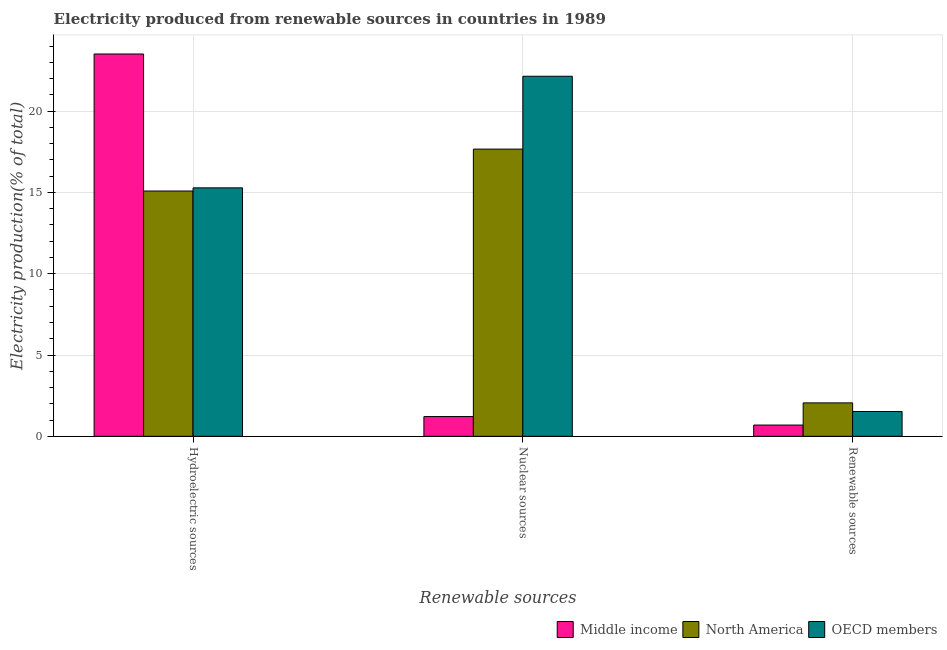How many different coloured bars are there?
Provide a succinct answer. 3. How many groups of bars are there?
Your answer should be very brief. 3. How many bars are there on the 3rd tick from the right?
Make the answer very short. 3. What is the label of the 3rd group of bars from the left?
Ensure brevity in your answer.  Renewable sources. What is the percentage of electricity produced by nuclear sources in North America?
Offer a very short reply. 17.66. Across all countries, what is the maximum percentage of electricity produced by hydroelectric sources?
Provide a short and direct response. 23.51. Across all countries, what is the minimum percentage of electricity produced by hydroelectric sources?
Offer a very short reply. 15.09. What is the total percentage of electricity produced by renewable sources in the graph?
Provide a succinct answer. 4.28. What is the difference between the percentage of electricity produced by nuclear sources in Middle income and that in North America?
Ensure brevity in your answer.  -16.45. What is the difference between the percentage of electricity produced by nuclear sources in North America and the percentage of electricity produced by renewable sources in Middle income?
Provide a short and direct response. 16.97. What is the average percentage of electricity produced by nuclear sources per country?
Provide a short and direct response. 13.68. What is the difference between the percentage of electricity produced by renewable sources and percentage of electricity produced by nuclear sources in North America?
Offer a very short reply. -15.61. In how many countries, is the percentage of electricity produced by nuclear sources greater than 7 %?
Make the answer very short. 2. What is the ratio of the percentage of electricity produced by nuclear sources in OECD members to that in North America?
Ensure brevity in your answer.  1.25. Is the percentage of electricity produced by renewable sources in North America less than that in OECD members?
Give a very brief answer. No. What is the difference between the highest and the second highest percentage of electricity produced by nuclear sources?
Offer a terse response. 4.48. What is the difference between the highest and the lowest percentage of electricity produced by nuclear sources?
Ensure brevity in your answer.  20.93. In how many countries, is the percentage of electricity produced by nuclear sources greater than the average percentage of electricity produced by nuclear sources taken over all countries?
Offer a very short reply. 2. How many bars are there?
Give a very brief answer. 9. How many countries are there in the graph?
Your answer should be very brief. 3. Does the graph contain any zero values?
Give a very brief answer. No. Does the graph contain grids?
Keep it short and to the point. Yes. Where does the legend appear in the graph?
Give a very brief answer. Bottom right. What is the title of the graph?
Make the answer very short. Electricity produced from renewable sources in countries in 1989. What is the label or title of the X-axis?
Provide a succinct answer. Renewable sources. What is the Electricity production(% of total) of Middle income in Hydroelectric sources?
Your answer should be compact. 23.51. What is the Electricity production(% of total) of North America in Hydroelectric sources?
Your response must be concise. 15.09. What is the Electricity production(% of total) in OECD members in Hydroelectric sources?
Provide a succinct answer. 15.28. What is the Electricity production(% of total) in Middle income in Nuclear sources?
Offer a terse response. 1.22. What is the Electricity production(% of total) of North America in Nuclear sources?
Provide a succinct answer. 17.66. What is the Electricity production(% of total) in OECD members in Nuclear sources?
Give a very brief answer. 22.15. What is the Electricity production(% of total) in Middle income in Renewable sources?
Offer a terse response. 0.69. What is the Electricity production(% of total) in North America in Renewable sources?
Give a very brief answer. 2.06. What is the Electricity production(% of total) in OECD members in Renewable sources?
Provide a short and direct response. 1.53. Across all Renewable sources, what is the maximum Electricity production(% of total) in Middle income?
Offer a terse response. 23.51. Across all Renewable sources, what is the maximum Electricity production(% of total) of North America?
Give a very brief answer. 17.66. Across all Renewable sources, what is the maximum Electricity production(% of total) in OECD members?
Offer a terse response. 22.15. Across all Renewable sources, what is the minimum Electricity production(% of total) in Middle income?
Offer a very short reply. 0.69. Across all Renewable sources, what is the minimum Electricity production(% of total) in North America?
Your response must be concise. 2.06. Across all Renewable sources, what is the minimum Electricity production(% of total) of OECD members?
Provide a succinct answer. 1.53. What is the total Electricity production(% of total) in Middle income in the graph?
Offer a terse response. 25.42. What is the total Electricity production(% of total) of North America in the graph?
Ensure brevity in your answer.  34.81. What is the total Electricity production(% of total) of OECD members in the graph?
Ensure brevity in your answer.  38.95. What is the difference between the Electricity production(% of total) of Middle income in Hydroelectric sources and that in Nuclear sources?
Keep it short and to the point. 22.3. What is the difference between the Electricity production(% of total) in North America in Hydroelectric sources and that in Nuclear sources?
Your response must be concise. -2.58. What is the difference between the Electricity production(% of total) in OECD members in Hydroelectric sources and that in Nuclear sources?
Offer a very short reply. -6.86. What is the difference between the Electricity production(% of total) of Middle income in Hydroelectric sources and that in Renewable sources?
Make the answer very short. 22.82. What is the difference between the Electricity production(% of total) in North America in Hydroelectric sources and that in Renewable sources?
Your response must be concise. 13.03. What is the difference between the Electricity production(% of total) of OECD members in Hydroelectric sources and that in Renewable sources?
Provide a short and direct response. 13.76. What is the difference between the Electricity production(% of total) in Middle income in Nuclear sources and that in Renewable sources?
Give a very brief answer. 0.52. What is the difference between the Electricity production(% of total) in North America in Nuclear sources and that in Renewable sources?
Offer a terse response. 15.61. What is the difference between the Electricity production(% of total) in OECD members in Nuclear sources and that in Renewable sources?
Provide a short and direct response. 20.62. What is the difference between the Electricity production(% of total) of Middle income in Hydroelectric sources and the Electricity production(% of total) of North America in Nuclear sources?
Provide a succinct answer. 5.85. What is the difference between the Electricity production(% of total) in Middle income in Hydroelectric sources and the Electricity production(% of total) in OECD members in Nuclear sources?
Your answer should be very brief. 1.37. What is the difference between the Electricity production(% of total) of North America in Hydroelectric sources and the Electricity production(% of total) of OECD members in Nuclear sources?
Make the answer very short. -7.06. What is the difference between the Electricity production(% of total) of Middle income in Hydroelectric sources and the Electricity production(% of total) of North America in Renewable sources?
Provide a succinct answer. 21.46. What is the difference between the Electricity production(% of total) of Middle income in Hydroelectric sources and the Electricity production(% of total) of OECD members in Renewable sources?
Make the answer very short. 21.99. What is the difference between the Electricity production(% of total) in North America in Hydroelectric sources and the Electricity production(% of total) in OECD members in Renewable sources?
Provide a succinct answer. 13.56. What is the difference between the Electricity production(% of total) of Middle income in Nuclear sources and the Electricity production(% of total) of North America in Renewable sources?
Offer a very short reply. -0.84. What is the difference between the Electricity production(% of total) in Middle income in Nuclear sources and the Electricity production(% of total) in OECD members in Renewable sources?
Provide a short and direct response. -0.31. What is the difference between the Electricity production(% of total) in North America in Nuclear sources and the Electricity production(% of total) in OECD members in Renewable sources?
Offer a very short reply. 16.14. What is the average Electricity production(% of total) in Middle income per Renewable sources?
Ensure brevity in your answer.  8.47. What is the average Electricity production(% of total) of North America per Renewable sources?
Give a very brief answer. 11.6. What is the average Electricity production(% of total) of OECD members per Renewable sources?
Your answer should be very brief. 12.98. What is the difference between the Electricity production(% of total) in Middle income and Electricity production(% of total) in North America in Hydroelectric sources?
Make the answer very short. 8.43. What is the difference between the Electricity production(% of total) of Middle income and Electricity production(% of total) of OECD members in Hydroelectric sources?
Offer a terse response. 8.23. What is the difference between the Electricity production(% of total) in North America and Electricity production(% of total) in OECD members in Hydroelectric sources?
Make the answer very short. -0.19. What is the difference between the Electricity production(% of total) in Middle income and Electricity production(% of total) in North America in Nuclear sources?
Offer a terse response. -16.45. What is the difference between the Electricity production(% of total) of Middle income and Electricity production(% of total) of OECD members in Nuclear sources?
Give a very brief answer. -20.93. What is the difference between the Electricity production(% of total) of North America and Electricity production(% of total) of OECD members in Nuclear sources?
Give a very brief answer. -4.48. What is the difference between the Electricity production(% of total) of Middle income and Electricity production(% of total) of North America in Renewable sources?
Your answer should be very brief. -1.36. What is the difference between the Electricity production(% of total) in Middle income and Electricity production(% of total) in OECD members in Renewable sources?
Keep it short and to the point. -0.83. What is the difference between the Electricity production(% of total) of North America and Electricity production(% of total) of OECD members in Renewable sources?
Your answer should be very brief. 0.53. What is the ratio of the Electricity production(% of total) of Middle income in Hydroelectric sources to that in Nuclear sources?
Your response must be concise. 19.34. What is the ratio of the Electricity production(% of total) in North America in Hydroelectric sources to that in Nuclear sources?
Make the answer very short. 0.85. What is the ratio of the Electricity production(% of total) in OECD members in Hydroelectric sources to that in Nuclear sources?
Your answer should be compact. 0.69. What is the ratio of the Electricity production(% of total) in Middle income in Hydroelectric sources to that in Renewable sources?
Provide a short and direct response. 33.92. What is the ratio of the Electricity production(% of total) of North America in Hydroelectric sources to that in Renewable sources?
Your answer should be compact. 7.34. What is the ratio of the Electricity production(% of total) in OECD members in Hydroelectric sources to that in Renewable sources?
Ensure brevity in your answer.  10.02. What is the ratio of the Electricity production(% of total) in Middle income in Nuclear sources to that in Renewable sources?
Keep it short and to the point. 1.75. What is the ratio of the Electricity production(% of total) in North America in Nuclear sources to that in Renewable sources?
Provide a short and direct response. 8.59. What is the ratio of the Electricity production(% of total) of OECD members in Nuclear sources to that in Renewable sources?
Your response must be concise. 14.52. What is the difference between the highest and the second highest Electricity production(% of total) in Middle income?
Keep it short and to the point. 22.3. What is the difference between the highest and the second highest Electricity production(% of total) of North America?
Offer a very short reply. 2.58. What is the difference between the highest and the second highest Electricity production(% of total) of OECD members?
Offer a very short reply. 6.86. What is the difference between the highest and the lowest Electricity production(% of total) in Middle income?
Make the answer very short. 22.82. What is the difference between the highest and the lowest Electricity production(% of total) in North America?
Keep it short and to the point. 15.61. What is the difference between the highest and the lowest Electricity production(% of total) in OECD members?
Offer a terse response. 20.62. 